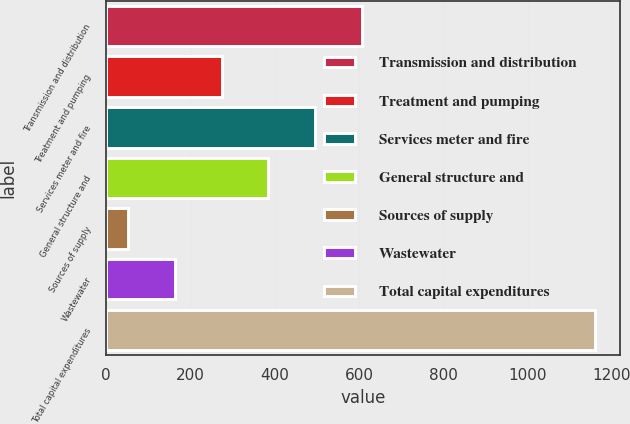Convert chart. <chart><loc_0><loc_0><loc_500><loc_500><bar_chart><fcel>Transmission and distribution<fcel>Treatment and pumping<fcel>Services meter and fire<fcel>General structure and<fcel>Sources of supply<fcel>Wastewater<fcel>Total capital expenditures<nl><fcel>606.5<fcel>274.4<fcel>495.8<fcel>385.1<fcel>53<fcel>163.7<fcel>1160<nl></chart> 